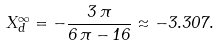Convert formula to latex. <formula><loc_0><loc_0><loc_500><loc_500>X _ { d } ^ { \infty } = - \frac { 3 \, \pi } { 6 \, \pi - 1 6 } \approx - 3 . 3 0 7 .</formula> 